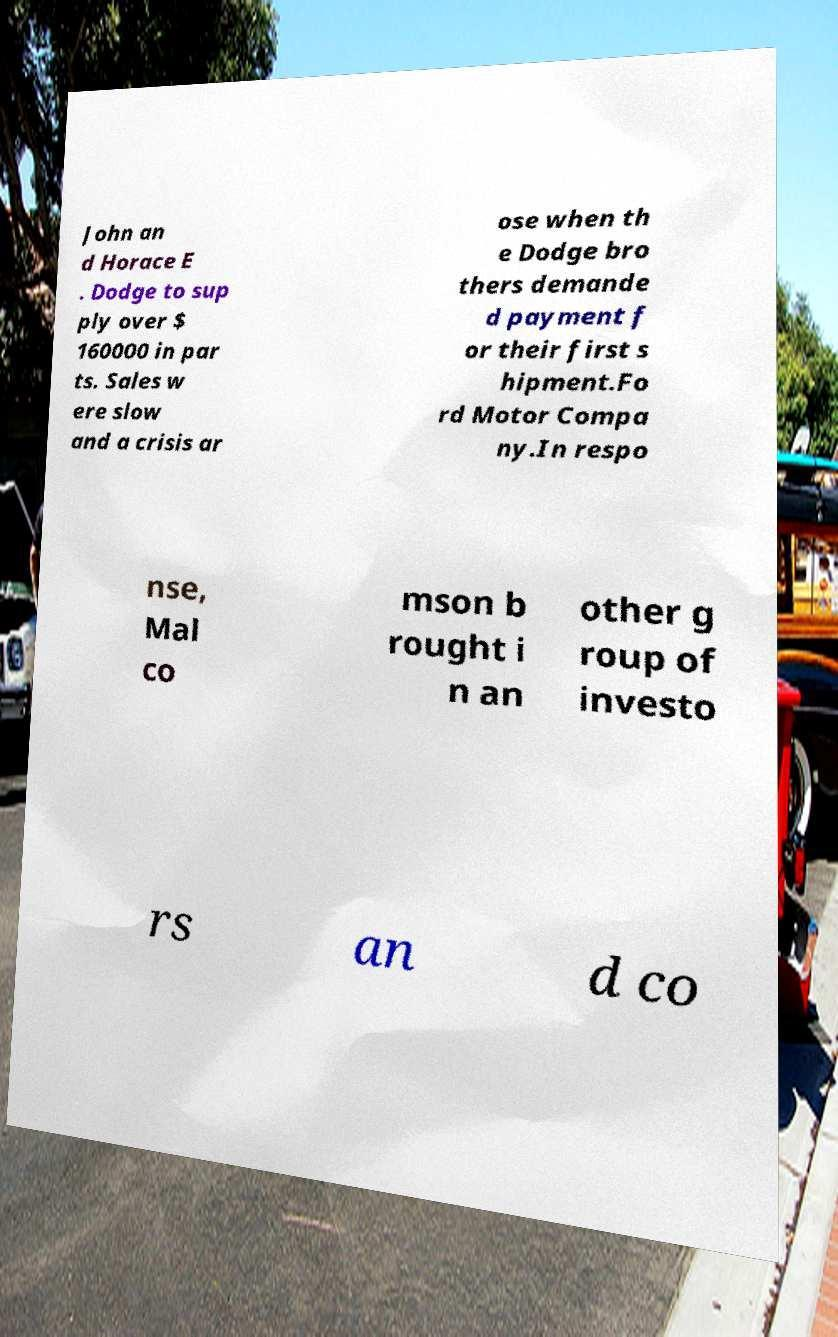Please identify and transcribe the text found in this image. John an d Horace E . Dodge to sup ply over $ 160000 in par ts. Sales w ere slow and a crisis ar ose when th e Dodge bro thers demande d payment f or their first s hipment.Fo rd Motor Compa ny.In respo nse, Mal co mson b rought i n an other g roup of investo rs an d co 